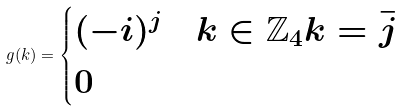<formula> <loc_0><loc_0><loc_500><loc_500>g ( k ) = \begin{cases} ( - i ) ^ { j } & k \in \mathbb { Z } _ { 4 } k = \bar { j } \\ 0 & \end{cases}</formula> 